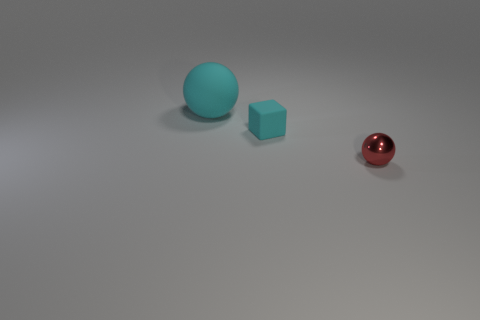Are there more tiny red things that are in front of the tiny ball than tiny green metallic cylinders?
Keep it short and to the point. No. What number of other objects are the same color as the tiny rubber object?
Offer a terse response. 1. There is a rubber thing that is the same size as the red metallic ball; what shape is it?
Provide a short and direct response. Cube. What number of red metallic spheres are in front of the small object that is on the right side of the cyan matte object that is in front of the big cyan thing?
Give a very brief answer. 0. What number of metallic things are either cyan blocks or tiny balls?
Ensure brevity in your answer.  1. There is a thing that is both in front of the big cyan rubber object and behind the small red metallic thing; what color is it?
Give a very brief answer. Cyan. There is a cyan thing that is behind the cyan rubber cube; does it have the same size as the small metallic ball?
Your answer should be compact. No. What number of things are tiny objects that are behind the red object or red shiny spheres?
Offer a terse response. 2. Are there any cyan rubber spheres of the same size as the metallic ball?
Offer a terse response. No. What material is the cube that is the same size as the red thing?
Provide a short and direct response. Rubber. 